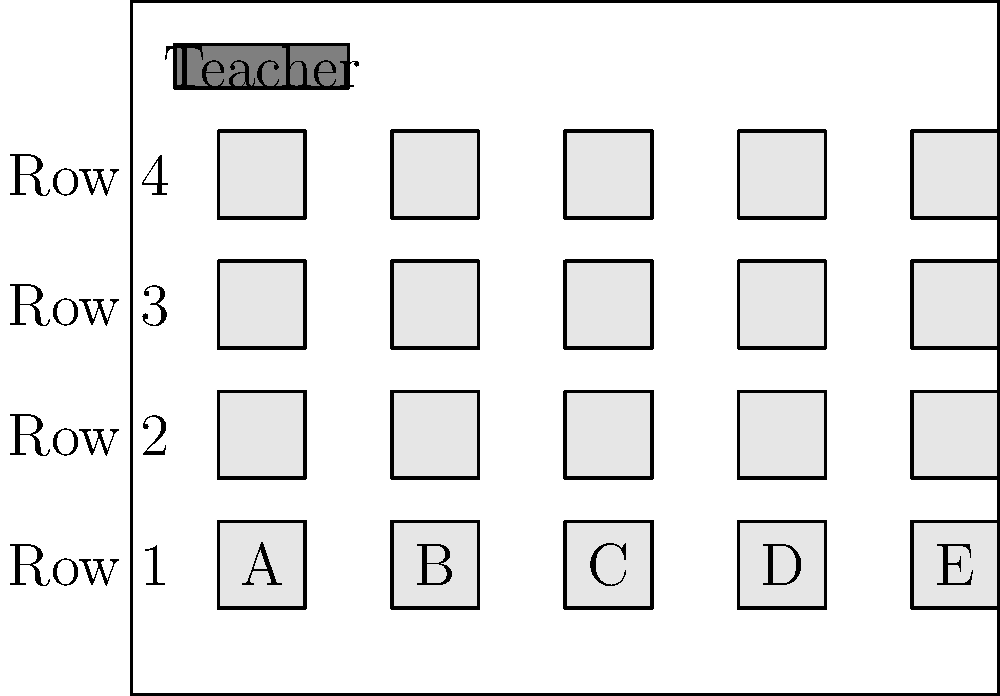As a single mother advocating for your child's educational needs, you're reviewing the classroom seating arrangement. If your child needs to be seated closer to the teacher due to visual impairment, which seat would you recommend? Assume the teacher primarily teaches from their desk. To determine the best seat for a child with visual impairment, we need to consider the proximity to the teacher's desk. Let's analyze the seating arrangement step-by-step:

1. The teacher's desk is located at the front of the classroom.
2. The classroom has 4 rows of desks, with 5 desks in each row (labeled A to E).
3. Row 1 is closest to the teacher's desk, followed by Rows 2, 3, and 4.
4. Within each row, Seat A is closest to the teacher's desk, followed by B, C, D, and E.

Given these observations:
1. Row 1 is the closest to the teacher's desk.
2. Within Row 1, Seat A is the closest to the teacher's desk.

Therefore, the seat that would be most suitable for a child with visual impairment, needing to be closer to the teacher, would be Seat A in Row 1.
Answer: Seat A in Row 1 